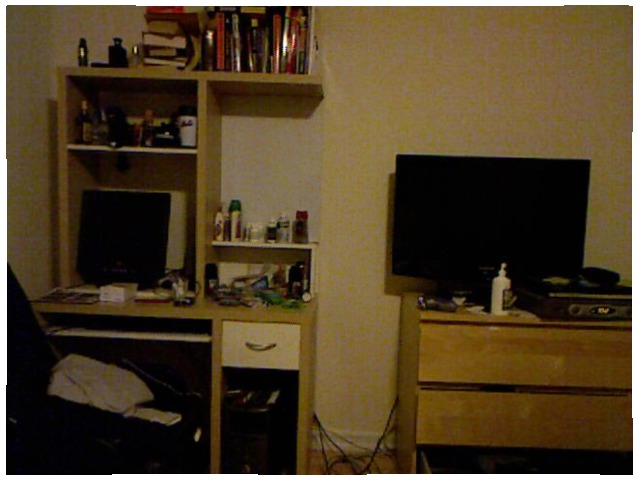<image>
Is there a contact solution in front of the tv? Yes. The contact solution is positioned in front of the tv, appearing closer to the camera viewpoint. Is there a books on the cupboard? Yes. Looking at the image, I can see the books is positioned on top of the cupboard, with the cupboard providing support. Is the tv above the drawer? No. The tv is not positioned above the drawer. The vertical arrangement shows a different relationship. 